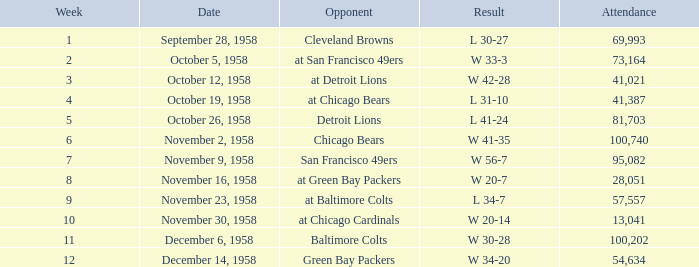What was the higest attendance on November 9, 1958? 95082.0. 